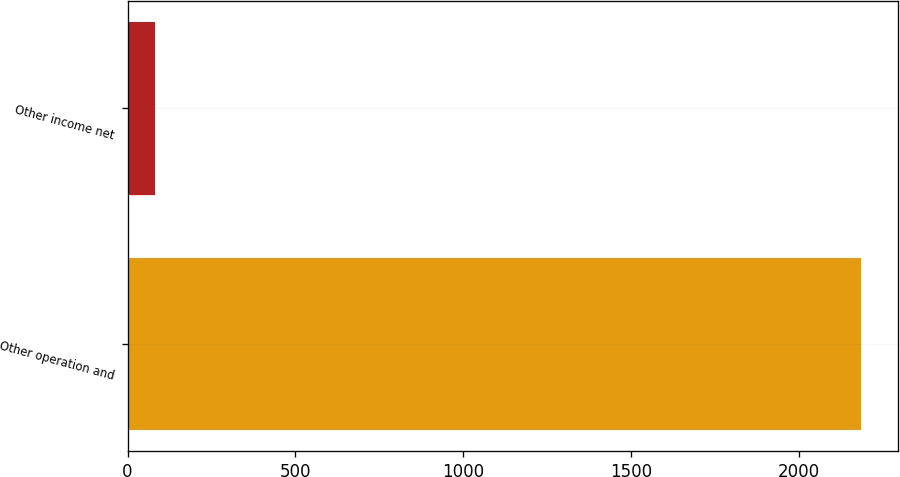<chart> <loc_0><loc_0><loc_500><loc_500><bar_chart><fcel>Other operation and<fcel>Other income net<nl><fcel>2185.5<fcel>80.8<nl></chart> 